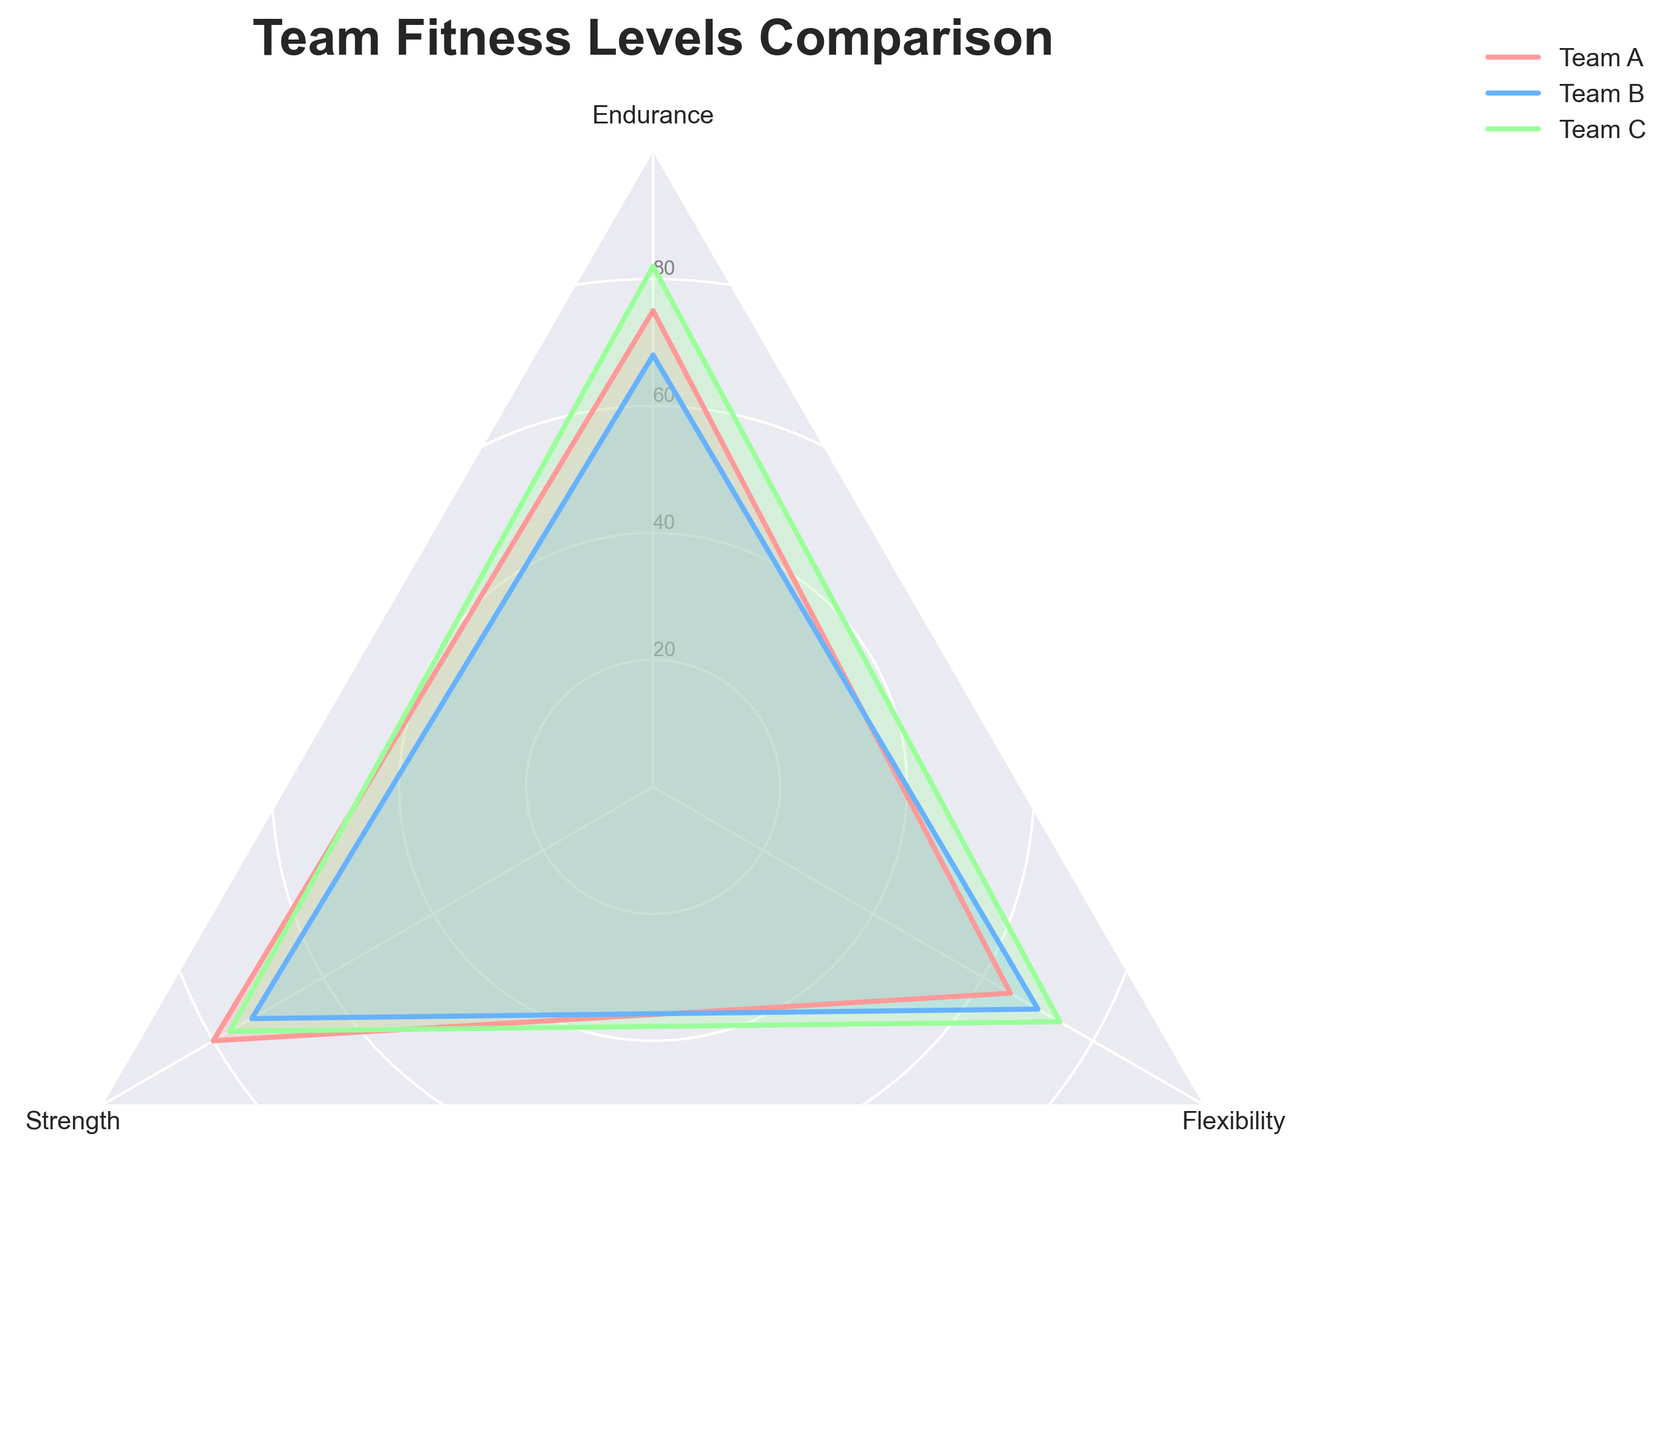what are the fitness categories shown in the radar chart? The categories displayed on the radar chart are provided on the axes labels. By looking at each axis of the radar chart, the categories identified are Endurance, Strength, and Flexibility.
Answer: Endurance, Strength, Flexibility Which team has the highest value in Endurance? To determine the team with the highest value in Endurance, observe the points plotted for each team in the Endurance category. Team C has the highest value at 82.
Answer: Team C What is the average Flexibility score across all three teams? Summing the flexibility scores for all three teams: 65 (Team A) + 70 (Team B) + 74 (Team C) = 209. Dividing this total by 3 gives an average score: 209 / 3 = 69.67. The average flexibility score is therefore approximately 69.67.
Answer: 69.67 Compare the Strength of Team A and Team B. Which team has a greater value? Looking at the Strength values, Team A has a score of 80, while Team B has a score of 73. Team A's Strength value is greater.
Answer: Team A Which team shows the most balanced performance across all categories? Observing the plots and how well each team covers all categories relatively equally, Team C shows relatively consistent values across all categories (Endurance: 82, Strength: 77, Flexibility: 74), indicating balanced performance.
Answer: Team C What is the range of values for Team B in the radar chart? The range is calculated by subtracting the minimum value from the maximum value in Team B's scores. The values for Team B are: 68 (Endurance), 73 (Strength), and 70 (Flexibility). The maximum value is 73 and the minimum is 68. Range is 73 - 68 = 5.
Answer: 5 Identify the team with the lowest Strength value and state that value. By examining the values for the Strength category, Team B has the lowest score, which is 73.
Answer: Team B, 73 Which fitness category shows the highest average score across all teams? To determine this, calculate the average score for each category: Endurance average = (75 + 68 + 82) / 3 = 75, Strength average = (80 + 73 + 77) / 3 = 76.67, Flexibility average = (65 + 70 + 74) / 3 = 69.67. The category with the highest average score is Strength.
Answer: Strength 